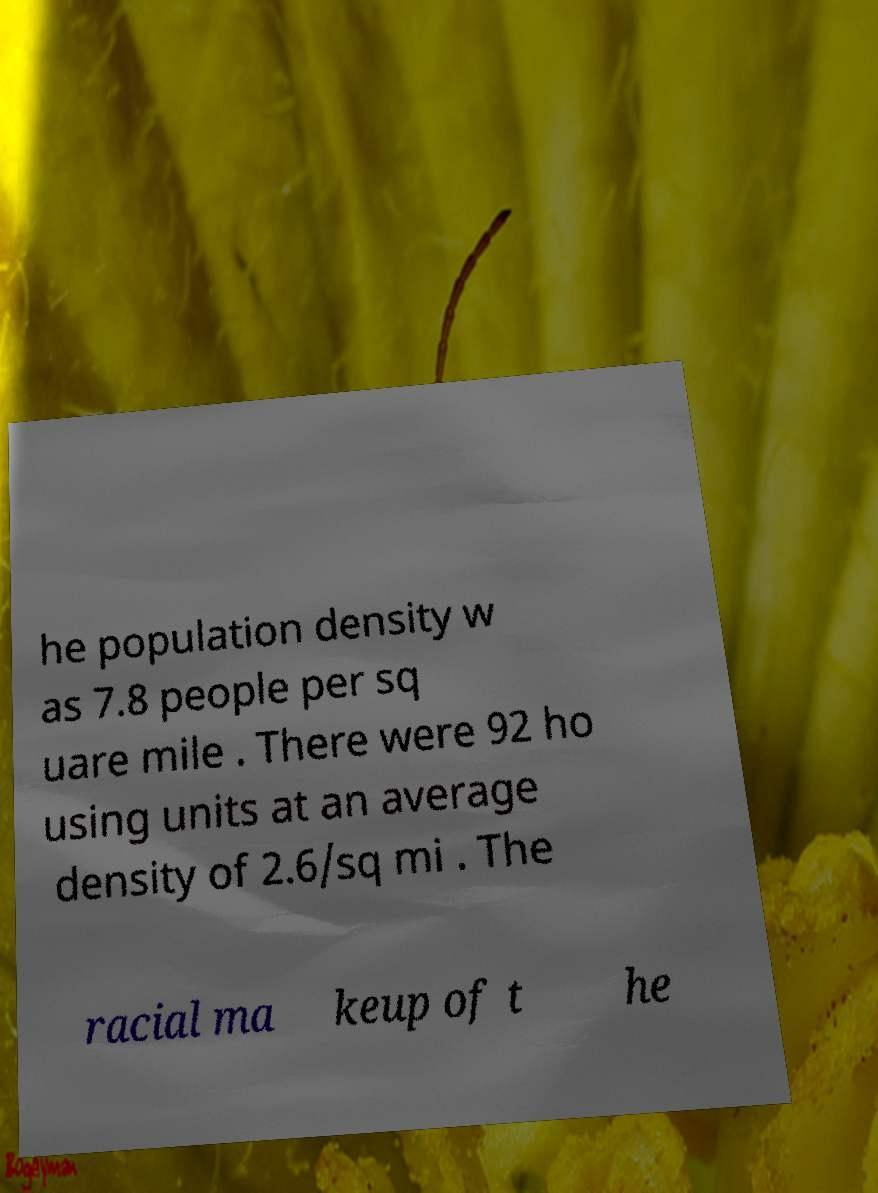There's text embedded in this image that I need extracted. Can you transcribe it verbatim? he population density w as 7.8 people per sq uare mile . There were 92 ho using units at an average density of 2.6/sq mi . The racial ma keup of t he 